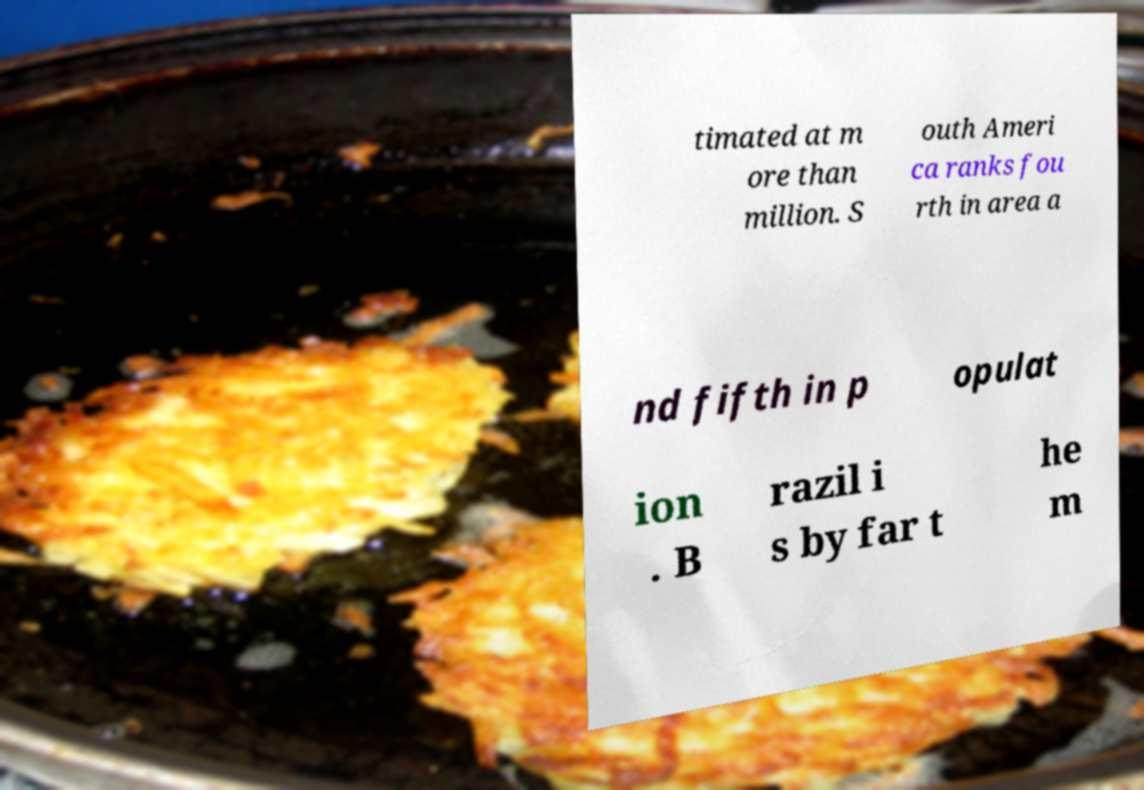I need the written content from this picture converted into text. Can you do that? timated at m ore than million. S outh Ameri ca ranks fou rth in area a nd fifth in p opulat ion . B razil i s by far t he m 